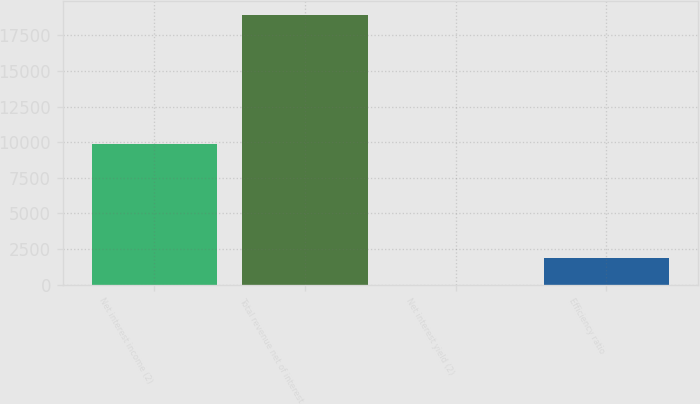<chart> <loc_0><loc_0><loc_500><loc_500><bar_chart><fcel>Net interest income (2)<fcel>Total revenue net of interest<fcel>Net interest yield (2)<fcel>Efficiency ratio<nl><fcel>9865<fcel>18955<fcel>2.18<fcel>1897.46<nl></chart> 